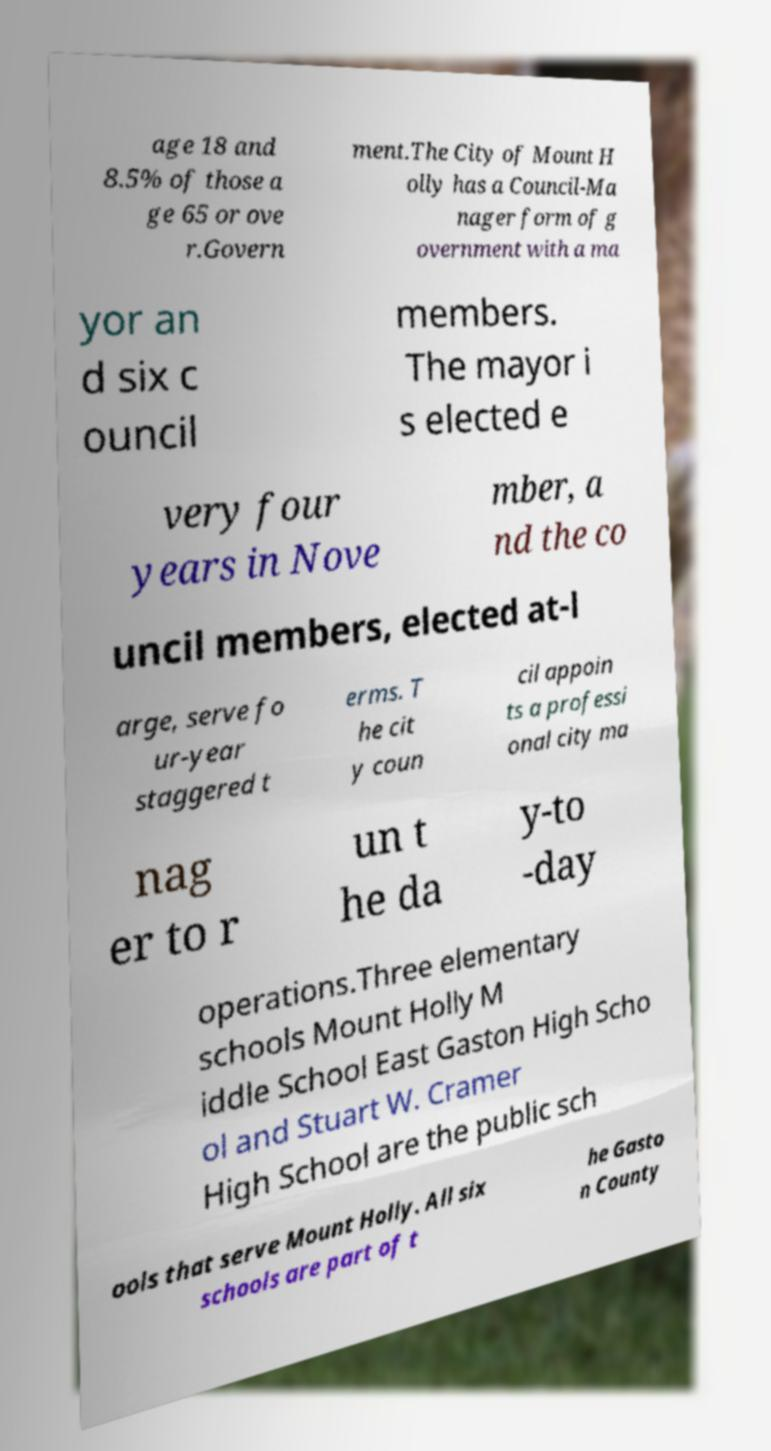What messages or text are displayed in this image? I need them in a readable, typed format. age 18 and 8.5% of those a ge 65 or ove r.Govern ment.The City of Mount H olly has a Council-Ma nager form of g overnment with a ma yor an d six c ouncil members. The mayor i s elected e very four years in Nove mber, a nd the co uncil members, elected at-l arge, serve fo ur-year staggered t erms. T he cit y coun cil appoin ts a professi onal city ma nag er to r un t he da y-to -day operations.Three elementary schools Mount Holly M iddle School East Gaston High Scho ol and Stuart W. Cramer High School are the public sch ools that serve Mount Holly. All six schools are part of t he Gasto n County 